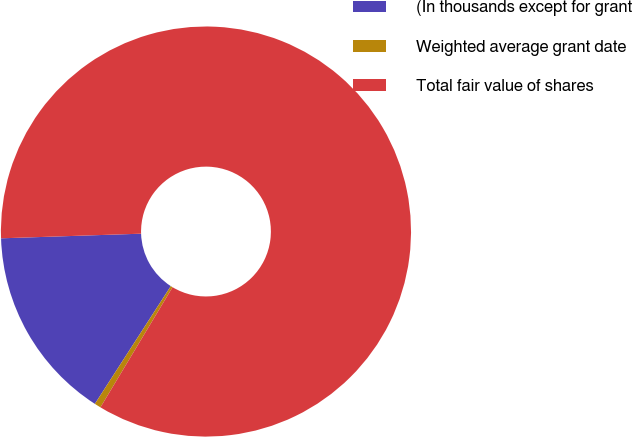Convert chart to OTSL. <chart><loc_0><loc_0><loc_500><loc_500><pie_chart><fcel>(In thousands except for grant<fcel>Weighted average grant date<fcel>Total fair value of shares<nl><fcel>15.36%<fcel>0.51%<fcel>84.13%<nl></chart> 